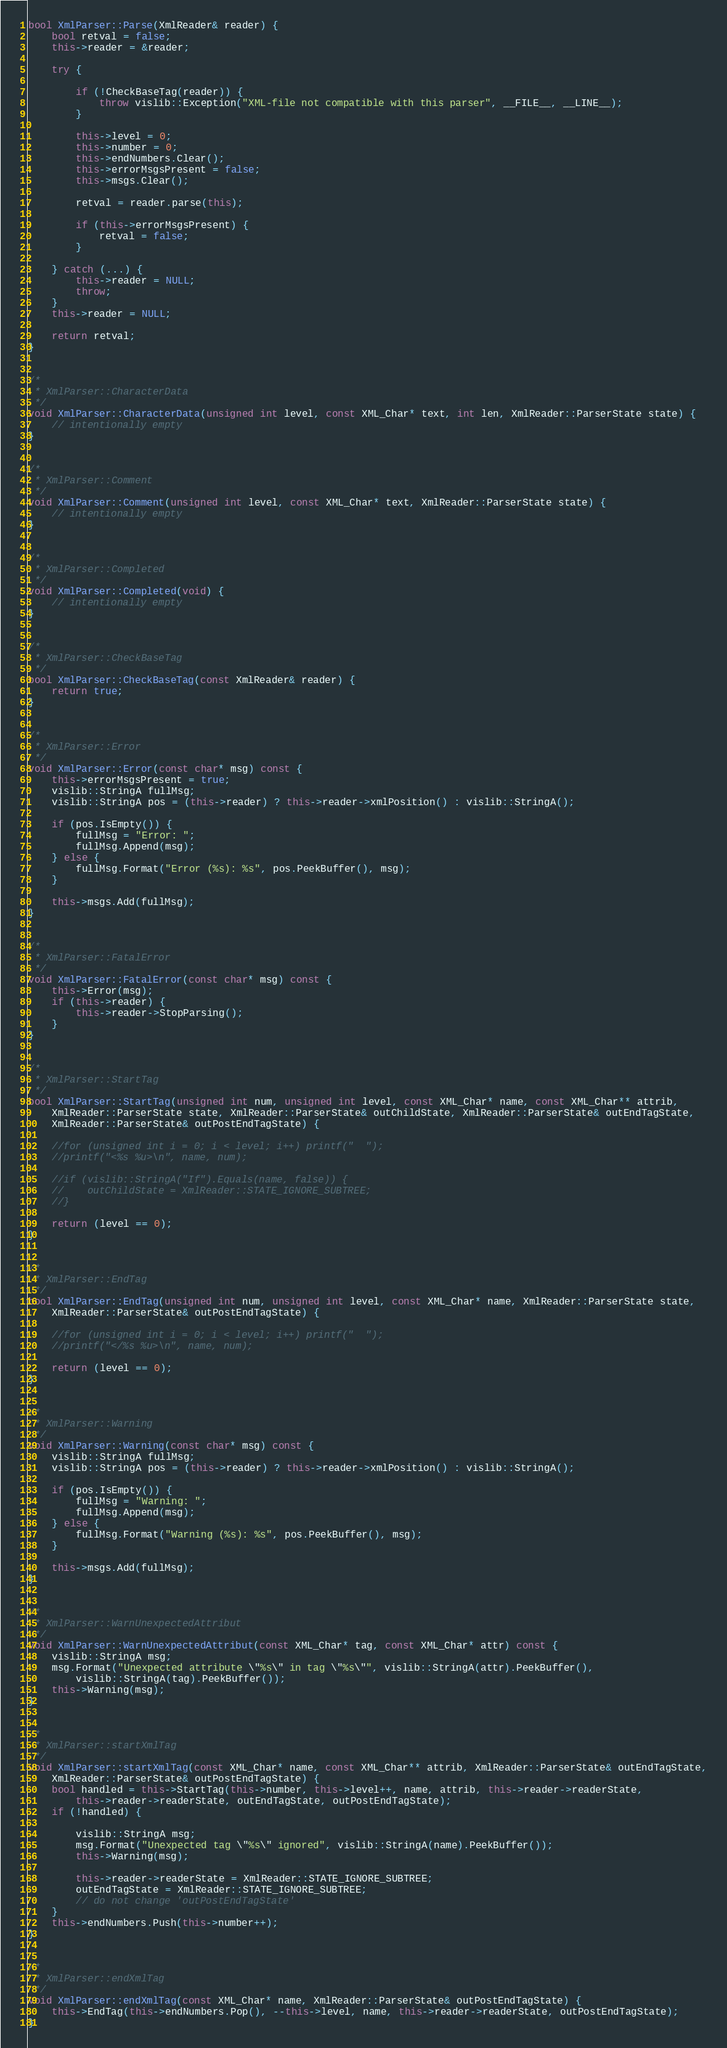Convert code to text. <code><loc_0><loc_0><loc_500><loc_500><_C++_>bool XmlParser::Parse(XmlReader& reader) {
    bool retval = false;
    this->reader = &reader;

    try {

        if (!CheckBaseTag(reader)) {
            throw vislib::Exception("XML-file not compatible with this parser", __FILE__, __LINE__);
        }

        this->level = 0;
        this->number = 0;
        this->endNumbers.Clear();
        this->errorMsgsPresent = false;
        this->msgs.Clear();

        retval = reader.parse(this);

        if (this->errorMsgsPresent) {
            retval = false;
        }

    } catch (...) {
        this->reader = NULL;
        throw;
    }
    this->reader = NULL;

    return retval;
}


/*
 * XmlParser::CharacterData
 */
void XmlParser::CharacterData(unsigned int level, const XML_Char* text, int len, XmlReader::ParserState state) {
    // intentionally empty
}


/*
 * XmlParser::Comment
 */
void XmlParser::Comment(unsigned int level, const XML_Char* text, XmlReader::ParserState state) {
    // intentionally empty
}


/*
 * XmlParser::Completed
 */
void XmlParser::Completed(void) {
    // intentionally empty
}


/*
 * XmlParser::CheckBaseTag
 */
bool XmlParser::CheckBaseTag(const XmlReader& reader) {
    return true;
}


/*
 * XmlParser::Error
 */
void XmlParser::Error(const char* msg) const {
    this->errorMsgsPresent = true;
    vislib::StringA fullMsg;
    vislib::StringA pos = (this->reader) ? this->reader->xmlPosition() : vislib::StringA();

    if (pos.IsEmpty()) {
        fullMsg = "Error: ";
        fullMsg.Append(msg);
    } else {
        fullMsg.Format("Error (%s): %s", pos.PeekBuffer(), msg);
    }

    this->msgs.Add(fullMsg);
}


/*
 * XmlParser::FatalError
 */
void XmlParser::FatalError(const char* msg) const {
    this->Error(msg);
    if (this->reader) {
        this->reader->StopParsing();
    }
}


/*
 * XmlParser::StartTag
 */
bool XmlParser::StartTag(unsigned int num, unsigned int level, const XML_Char* name, const XML_Char** attrib,
    XmlReader::ParserState state, XmlReader::ParserState& outChildState, XmlReader::ParserState& outEndTagState,
    XmlReader::ParserState& outPostEndTagState) {

    //for (unsigned int i = 0; i < level; i++) printf("  ");
    //printf("<%s %u>\n", name, num);

    //if (vislib::StringA("If").Equals(name, false)) {
    //    outChildState = XmlReader::STATE_IGNORE_SUBTREE;
    //}

    return (level == 0);
}


/*
 * XmlParser::EndTag
 */
bool XmlParser::EndTag(unsigned int num, unsigned int level, const XML_Char* name, XmlReader::ParserState state,
    XmlReader::ParserState& outPostEndTagState) {

    //for (unsigned int i = 0; i < level; i++) printf("  ");
    //printf("</%s %u>\n", name, num);

    return (level == 0);
}


/*
 * XmlParser::Warning
 */
void XmlParser::Warning(const char* msg) const {
    vislib::StringA fullMsg;
    vislib::StringA pos = (this->reader) ? this->reader->xmlPosition() : vislib::StringA();

    if (pos.IsEmpty()) {
        fullMsg = "Warning: ";
        fullMsg.Append(msg);
    } else {
        fullMsg.Format("Warning (%s): %s", pos.PeekBuffer(), msg);
    }

    this->msgs.Add(fullMsg);
}


/*
 * XmlParser::WarnUnexpectedAttribut
 */
void XmlParser::WarnUnexpectedAttribut(const XML_Char* tag, const XML_Char* attr) const {
    vislib::StringA msg;
    msg.Format("Unexpected attribute \"%s\" in tag \"%s\"", vislib::StringA(attr).PeekBuffer(),
        vislib::StringA(tag).PeekBuffer());
    this->Warning(msg);
}


/*
 * XmlParser::startXmlTag
 */
void XmlParser::startXmlTag(const XML_Char* name, const XML_Char** attrib, XmlReader::ParserState& outEndTagState,
    XmlReader::ParserState& outPostEndTagState) {
    bool handled = this->StartTag(this->number, this->level++, name, attrib, this->reader->readerState,
        this->reader->readerState, outEndTagState, outPostEndTagState);
    if (!handled) {

        vislib::StringA msg;
        msg.Format("Unexpected tag \"%s\" ignored", vislib::StringA(name).PeekBuffer());
        this->Warning(msg);

        this->reader->readerState = XmlReader::STATE_IGNORE_SUBTREE;
        outEndTagState = XmlReader::STATE_IGNORE_SUBTREE;
        // do not change 'outPostEndTagState'
    }
    this->endNumbers.Push(this->number++);
}


/*
 * XmlParser::endXmlTag
 */
void XmlParser::endXmlTag(const XML_Char* name, XmlReader::ParserState& outPostEndTagState) {
    this->EndTag(this->endNumbers.Pop(), --this->level, name, this->reader->readerState, outPostEndTagState);
}
</code> 